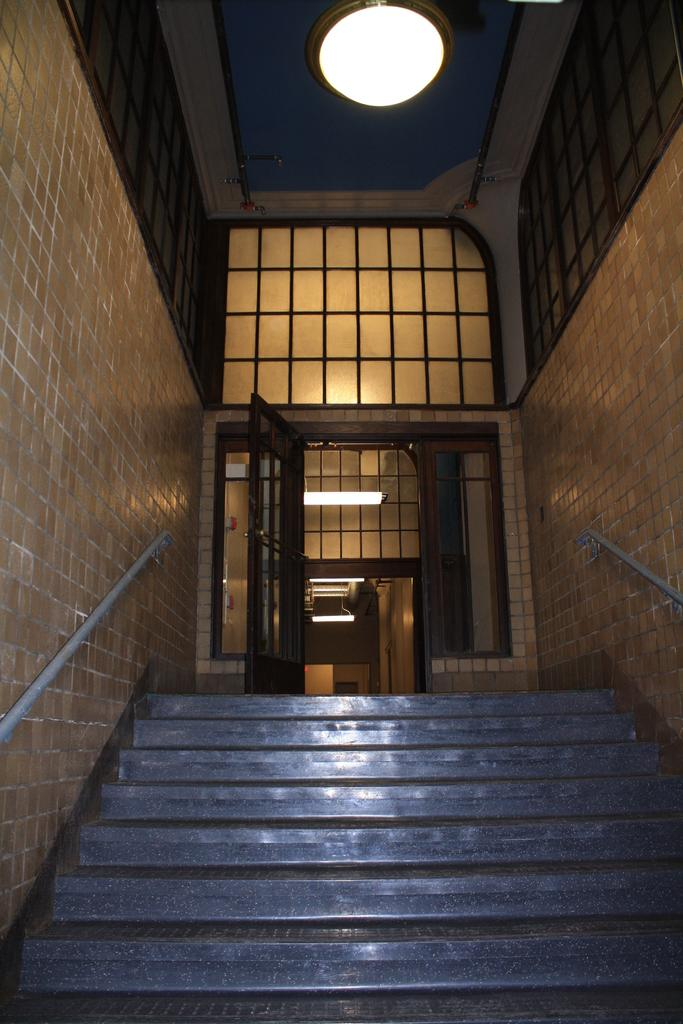What type of structure is present in the image? There is a building in the image. What is on the roof of the building? There are states and light on the roof of the building. Can you describe the entrance to the building? There is a door visible in the image. How many cats can be seen playing in the camp near the building in the image? There are no cats or camp present in the image; it only features a building with states and light on the roof. 